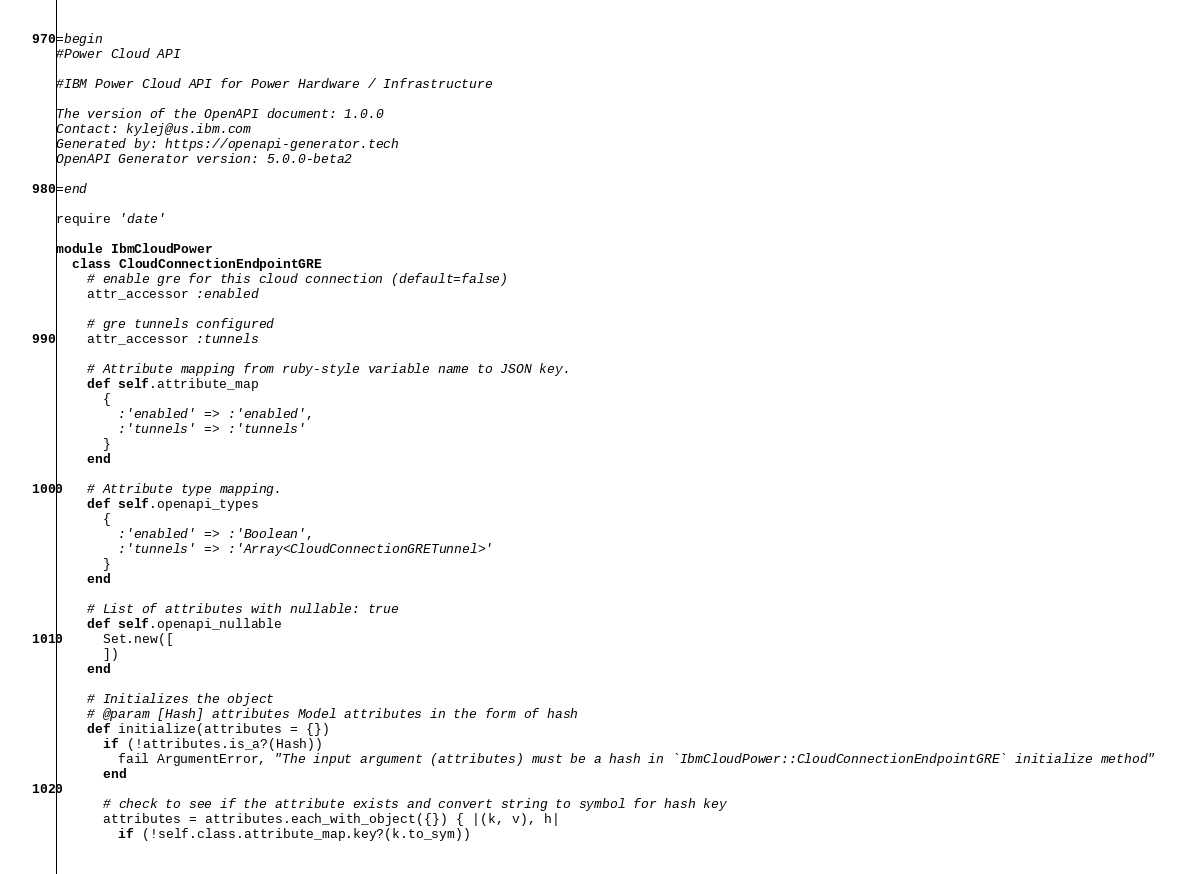Convert code to text. <code><loc_0><loc_0><loc_500><loc_500><_Ruby_>=begin
#Power Cloud API

#IBM Power Cloud API for Power Hardware / Infrastructure

The version of the OpenAPI document: 1.0.0
Contact: kylej@us.ibm.com
Generated by: https://openapi-generator.tech
OpenAPI Generator version: 5.0.0-beta2

=end

require 'date'

module IbmCloudPower
  class CloudConnectionEndpointGRE
    # enable gre for this cloud connection (default=false)
    attr_accessor :enabled

    # gre tunnels configured
    attr_accessor :tunnels

    # Attribute mapping from ruby-style variable name to JSON key.
    def self.attribute_map
      {
        :'enabled' => :'enabled',
        :'tunnels' => :'tunnels'
      }
    end

    # Attribute type mapping.
    def self.openapi_types
      {
        :'enabled' => :'Boolean',
        :'tunnels' => :'Array<CloudConnectionGRETunnel>'
      }
    end

    # List of attributes with nullable: true
    def self.openapi_nullable
      Set.new([
      ])
    end

    # Initializes the object
    # @param [Hash] attributes Model attributes in the form of hash
    def initialize(attributes = {})
      if (!attributes.is_a?(Hash))
        fail ArgumentError, "The input argument (attributes) must be a hash in `IbmCloudPower::CloudConnectionEndpointGRE` initialize method"
      end

      # check to see if the attribute exists and convert string to symbol for hash key
      attributes = attributes.each_with_object({}) { |(k, v), h|
        if (!self.class.attribute_map.key?(k.to_sym))</code> 